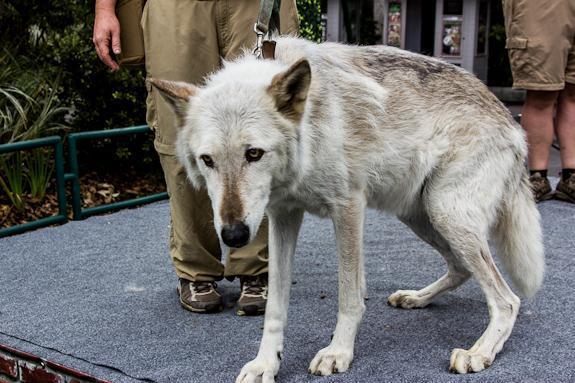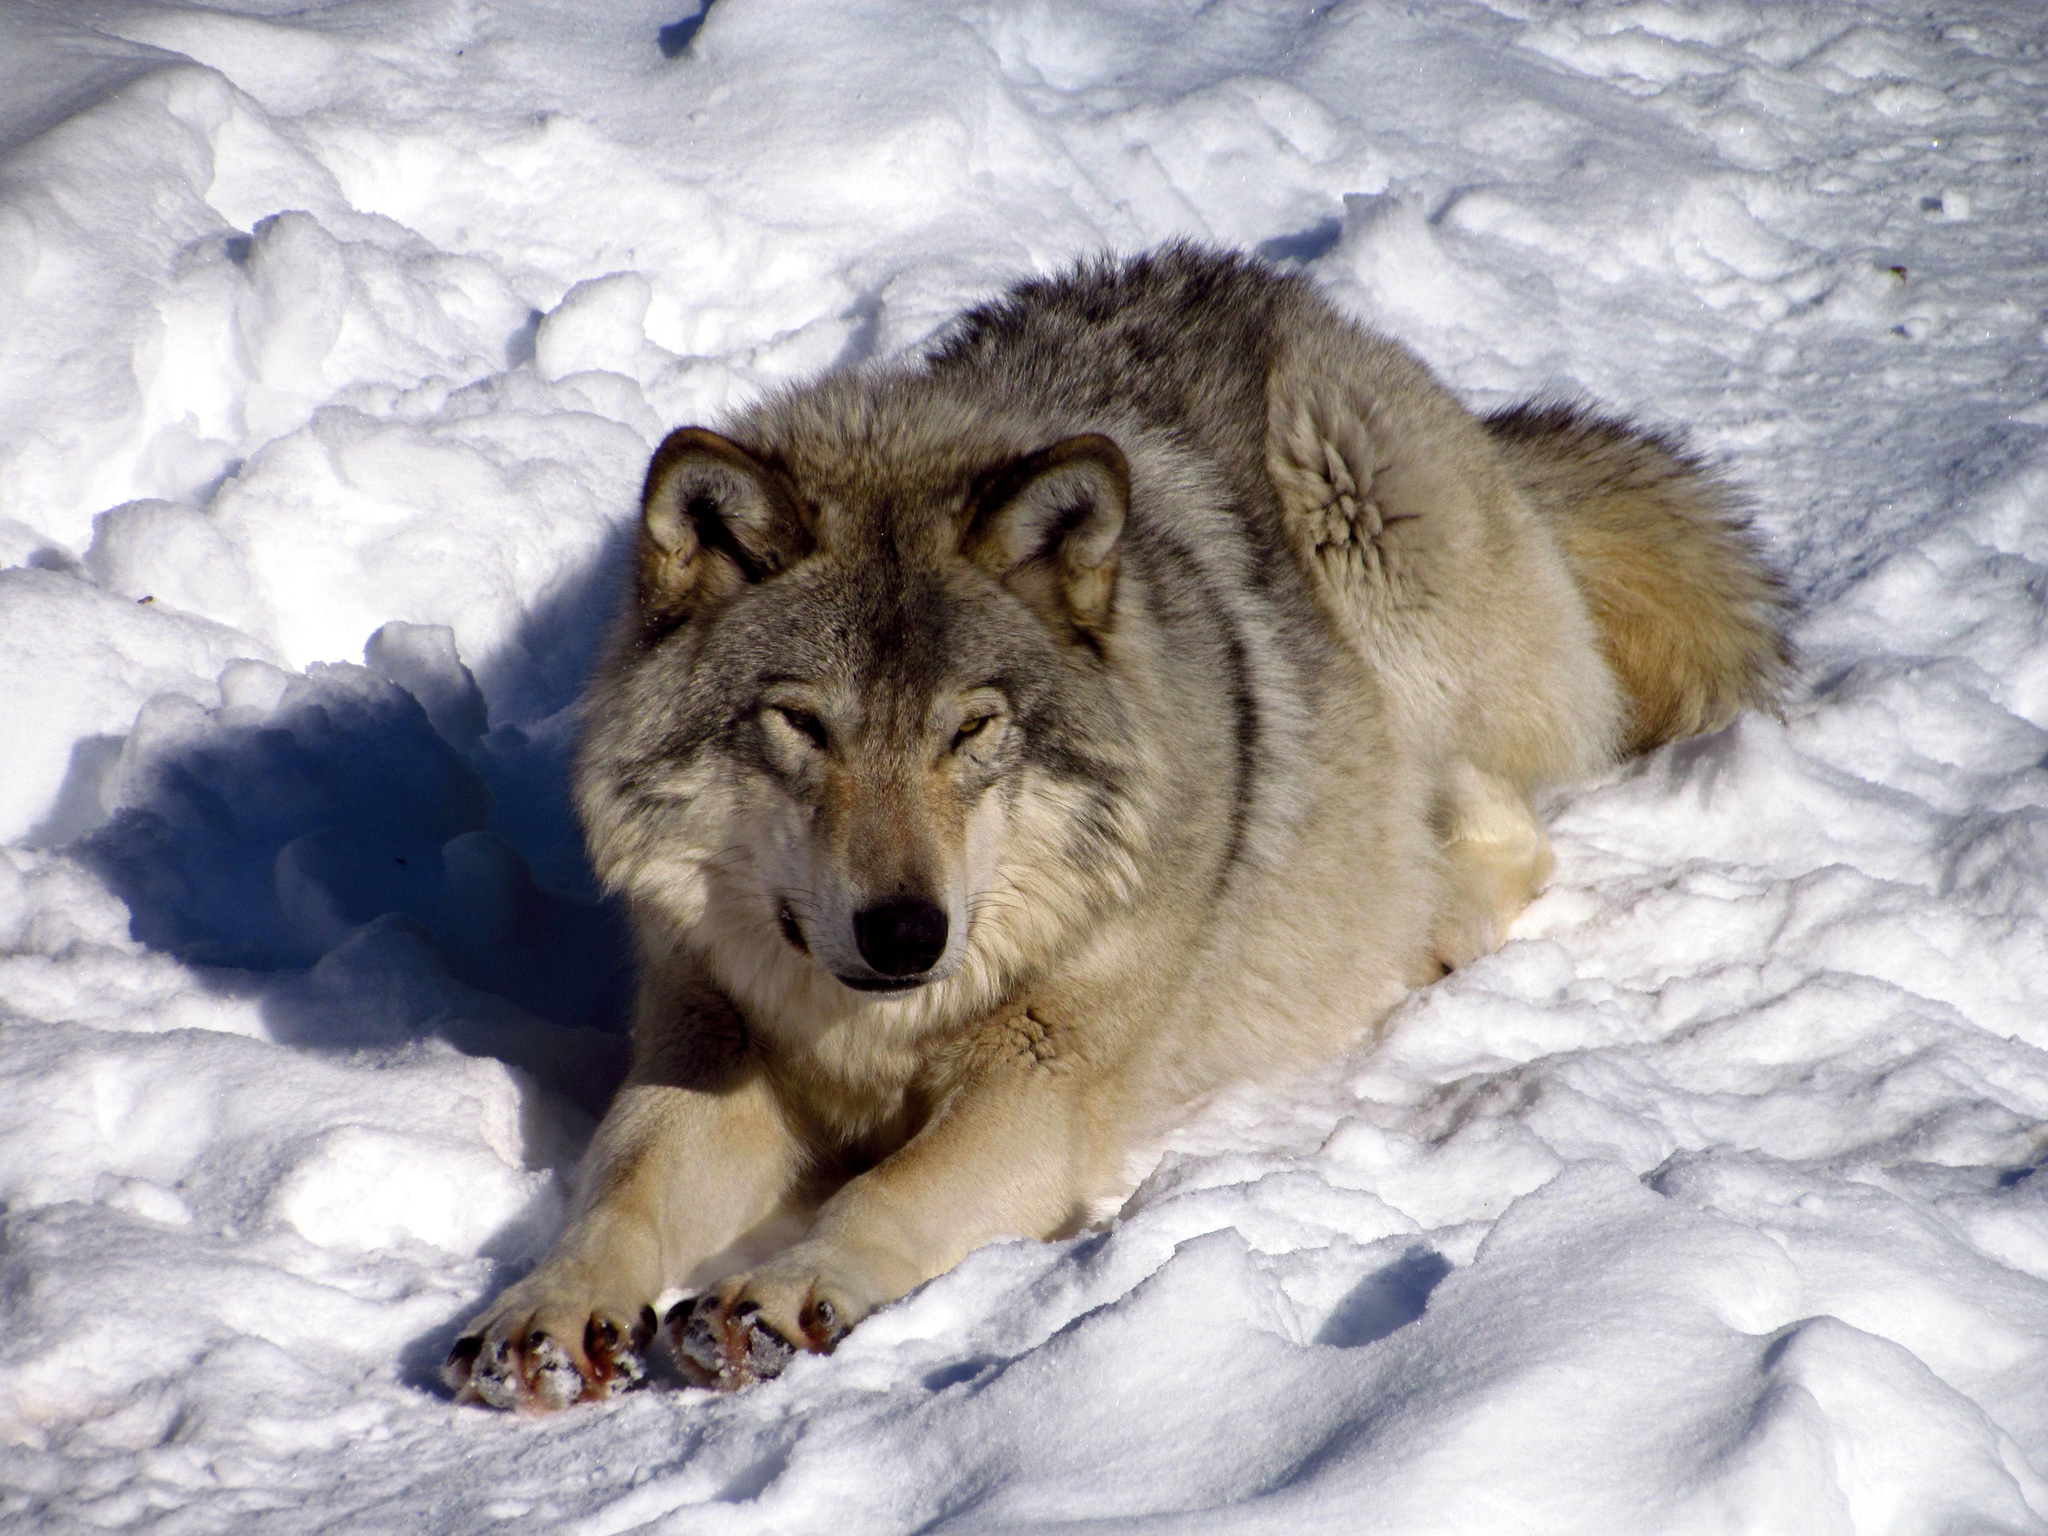The first image is the image on the left, the second image is the image on the right. Evaluate the accuracy of this statement regarding the images: "The animal in the image on the left is on snow.". Is it true? Answer yes or no. No. The first image is the image on the left, the second image is the image on the right. For the images displayed, is the sentence "An image shows a tawny wolf lying on the ground with front paws forward and head up." factually correct? Answer yes or no. Yes. The first image is the image on the left, the second image is the image on the right. Examine the images to the left and right. Is the description "In 1 of the images, 1 wolf is seated in snow." accurate? Answer yes or no. Yes. The first image is the image on the left, the second image is the image on the right. Analyze the images presented: Is the assertion "An image shows one wolf resting on the snow with front paws extended forward." valid? Answer yes or no. Yes. 